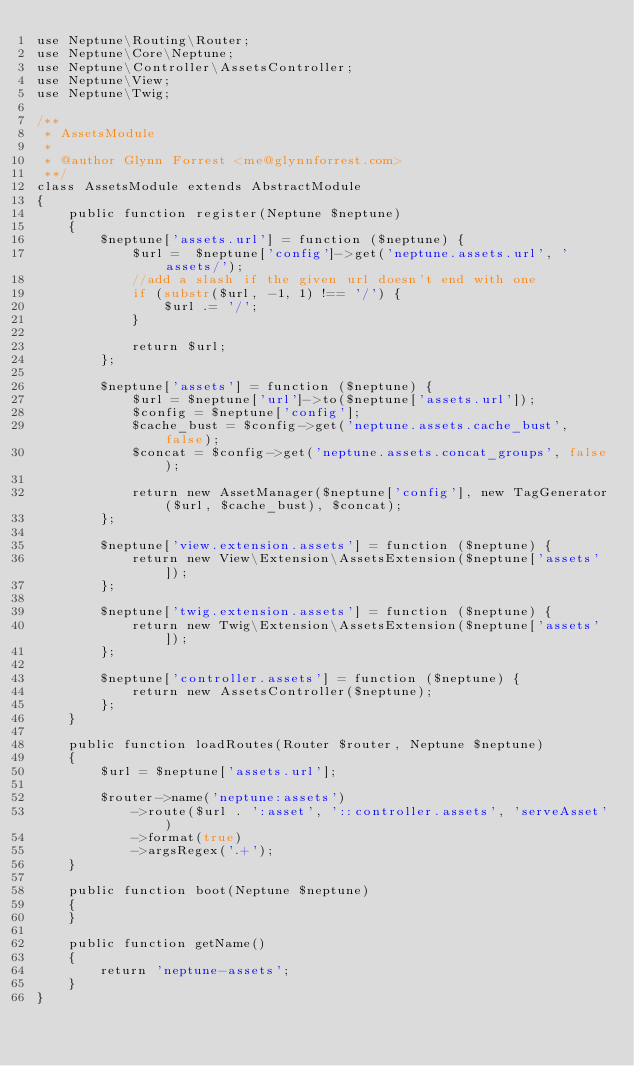Convert code to text. <code><loc_0><loc_0><loc_500><loc_500><_PHP_>use Neptune\Routing\Router;
use Neptune\Core\Neptune;
use Neptune\Controller\AssetsController;
use Neptune\View;
use Neptune\Twig;

/**
 * AssetsModule
 *
 * @author Glynn Forrest <me@glynnforrest.com>
 **/
class AssetsModule extends AbstractModule
{
    public function register(Neptune $neptune)
    {
        $neptune['assets.url'] = function ($neptune) {
            $url =  $neptune['config']->get('neptune.assets.url', 'assets/');
            //add a slash if the given url doesn't end with one
            if (substr($url, -1, 1) !== '/') {
                $url .= '/';
            }

            return $url;
        };

        $neptune['assets'] = function ($neptune) {
            $url = $neptune['url']->to($neptune['assets.url']);
            $config = $neptune['config'];
            $cache_bust = $config->get('neptune.assets.cache_bust', false);
            $concat = $config->get('neptune.assets.concat_groups', false);

            return new AssetManager($neptune['config'], new TagGenerator($url, $cache_bust), $concat);
        };

        $neptune['view.extension.assets'] = function ($neptune) {
            return new View\Extension\AssetsExtension($neptune['assets']);
        };

        $neptune['twig.extension.assets'] = function ($neptune) {
            return new Twig\Extension\AssetsExtension($neptune['assets']);
        };

        $neptune['controller.assets'] = function ($neptune) {
            return new AssetsController($neptune);
        };
    }

    public function loadRoutes(Router $router, Neptune $neptune)
    {
        $url = $neptune['assets.url'];

        $router->name('neptune:assets')
            ->route($url . ':asset', '::controller.assets', 'serveAsset')
            ->format(true)
            ->argsRegex('.+');
    }

    public function boot(Neptune $neptune)
    {
    }

    public function getName()
    {
        return 'neptune-assets';
    }
}
</code> 